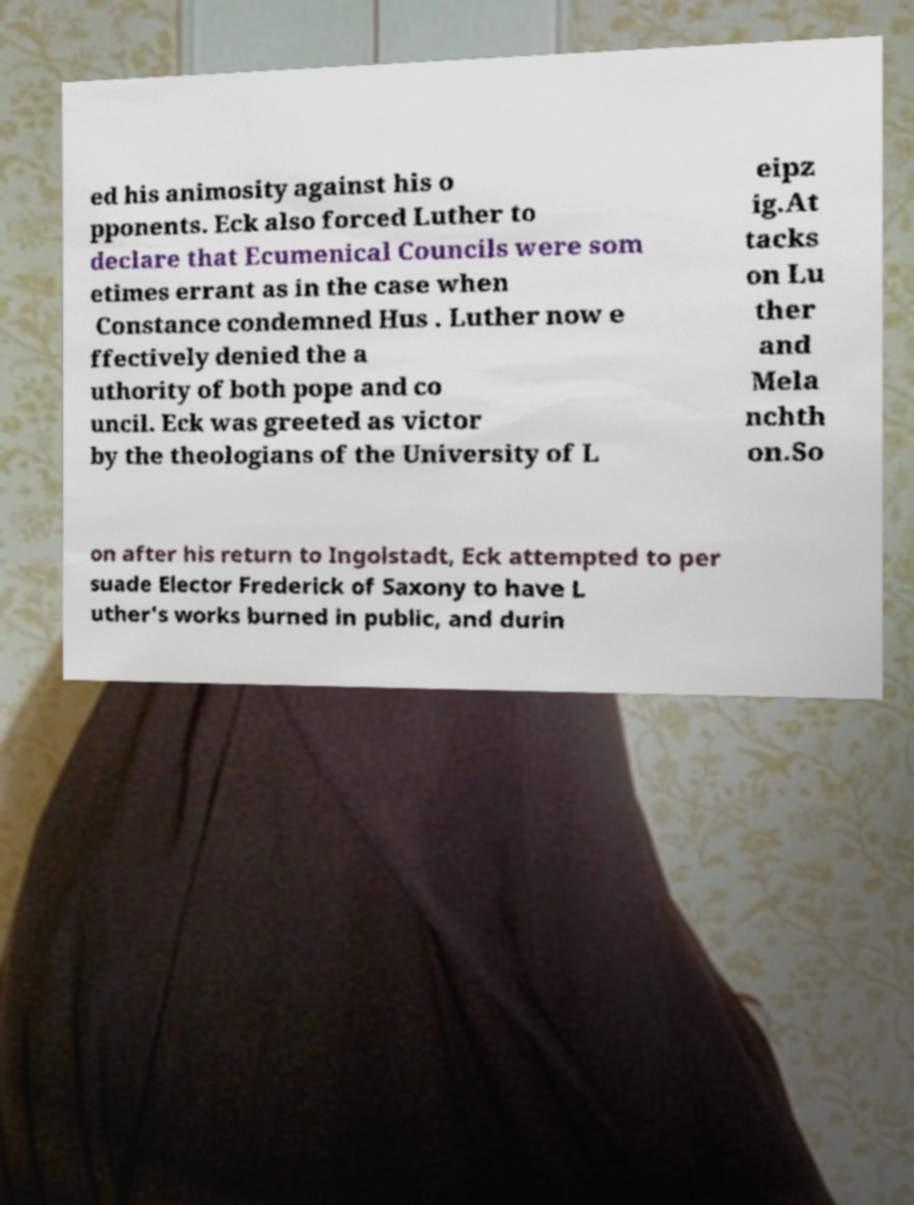Please read and relay the text visible in this image. What does it say? ed his animosity against his o pponents. Eck also forced Luther to declare that Ecumenical Councils were som etimes errant as in the case when Constance condemned Hus . Luther now e ffectively denied the a uthority of both pope and co uncil. Eck was greeted as victor by the theologians of the University of L eipz ig.At tacks on Lu ther and Mela nchth on.So on after his return to Ingolstadt, Eck attempted to per suade Elector Frederick of Saxony to have L uther's works burned in public, and durin 